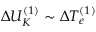<formula> <loc_0><loc_0><loc_500><loc_500>\Delta U _ { K } ^ { ( 1 ) } \sim \Delta T _ { e } ^ { ( 1 ) }</formula> 